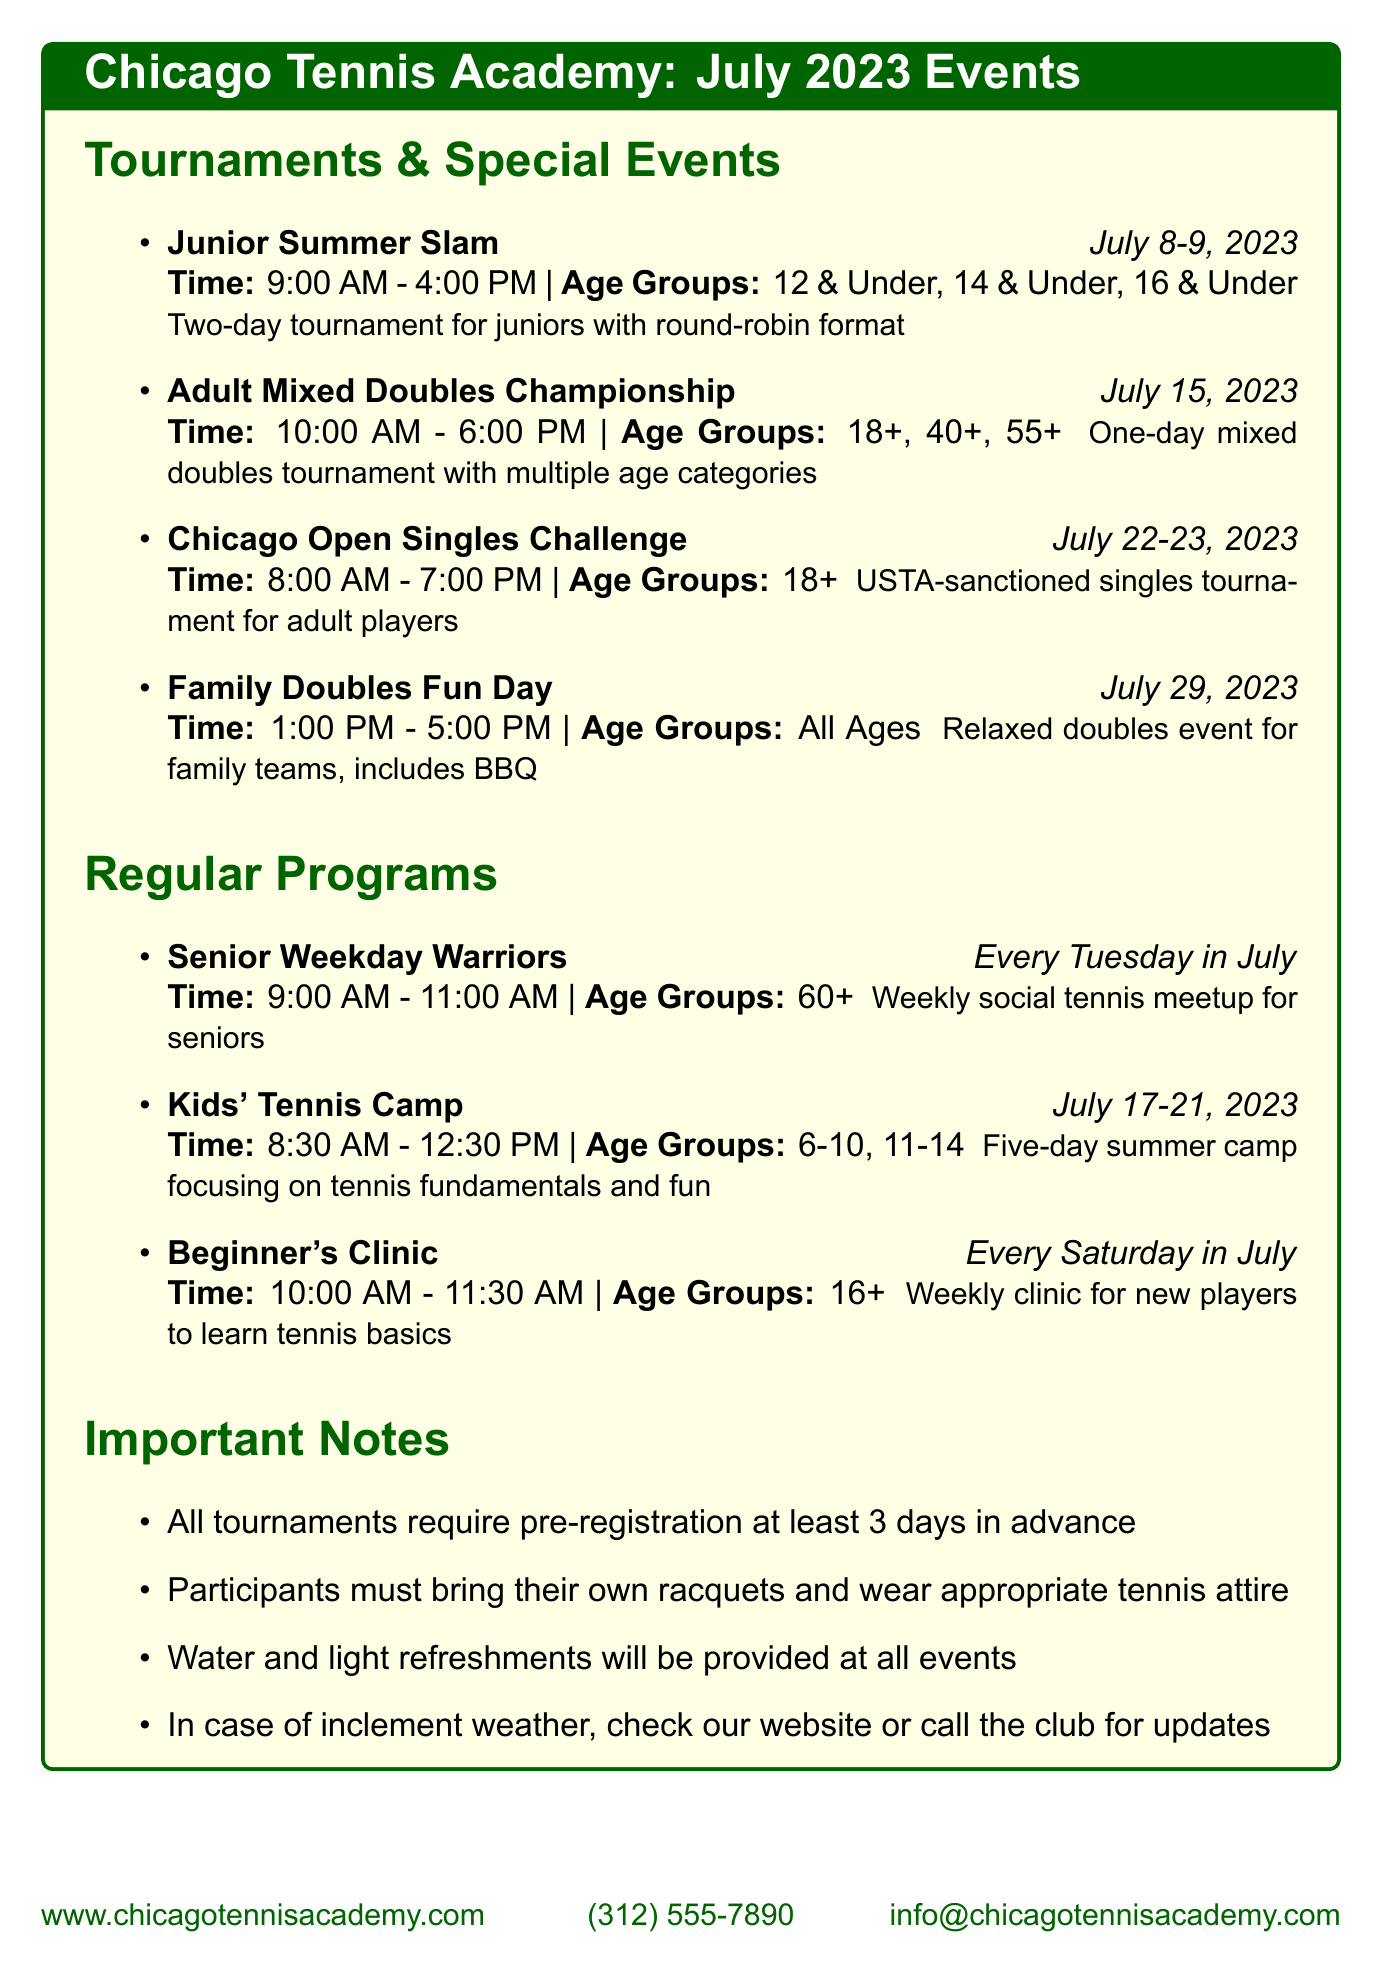what are the dates for the Junior Summer Slam? The dates for the Junior Summer Slam are provided in the document, which states it occurs on July 8-9, 2023.
Answer: July 8-9, 2023 what time does the Adult Mixed Doubles Championship start? The document lists the time for the Adult Mixed Doubles Championship, which begins at 10:00 AM.
Answer: 10:00 AM who can participate in the Family Doubles Fun Day? The document indicates the age groups for the Family Doubles Fun Day, which is open to "All Ages."
Answer: All Ages how often do the Senior Weekday Warriors meet? The document details that the Senior Weekday Warriors meet "Every Tuesday in July," indicating a weekly occurrence.
Answer: Every Tuesday in July how long does the Kids' Tennis Camp last? The duration of the Kids' Tennis Camp is specified in the document as a five-day event from July 17-21, 2023.
Answer: Five days what is required for all tournament registrations? The document states that all tournaments require pre-registration at least three days in advance, highlighting the registration policy.
Answer: Pre-registration at least 3 days in advance what type of tournament is the Chicago Open Singles Challenge? The Chicago Open Singles Challenge is described in the document as a USTA-sanctioned singles tournament for adult players.
Answer: USTA-sanctioned singles tournament what is provided at all events? The document mentions that water and light refreshments will be provided at all events, indicating the amenities available.
Answer: Water and light refreshments 